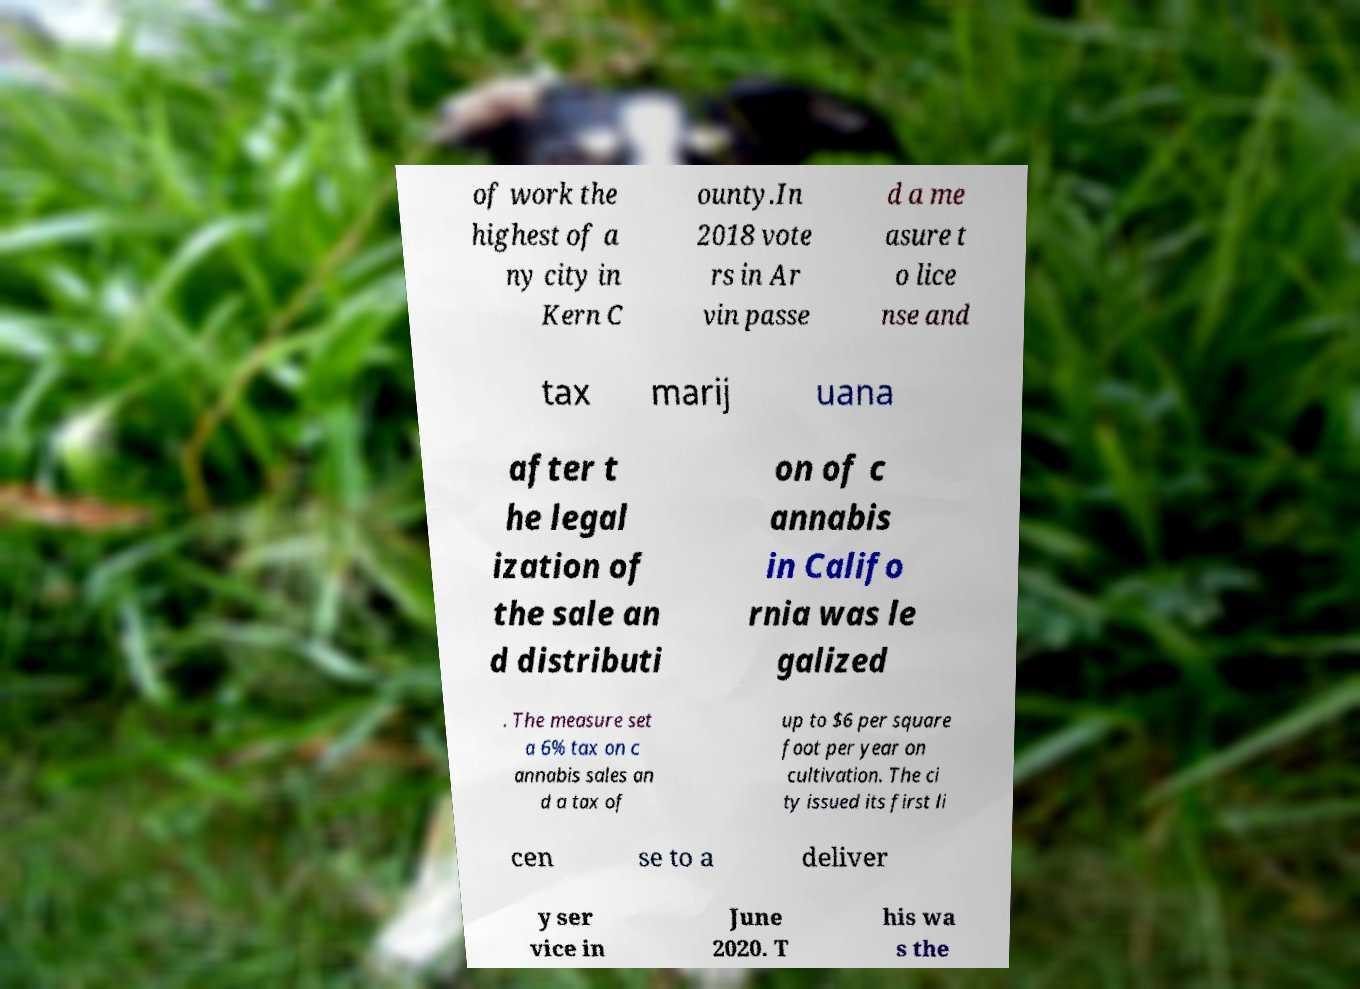I need the written content from this picture converted into text. Can you do that? of work the highest of a ny city in Kern C ounty.In 2018 vote rs in Ar vin passe d a me asure t o lice nse and tax marij uana after t he legal ization of the sale an d distributi on of c annabis in Califo rnia was le galized . The measure set a 6% tax on c annabis sales an d a tax of up to $6 per square foot per year on cultivation. The ci ty issued its first li cen se to a deliver y ser vice in June 2020. T his wa s the 